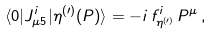<formula> <loc_0><loc_0><loc_500><loc_500>\langle 0 | J _ { \mu 5 } ^ { i } | \eta ^ { ( \prime ) } ( P ) \rangle = - i \, f _ { \eta ^ { ( \prime ) } } ^ { i } \, P ^ { \mu } \, ,</formula> 